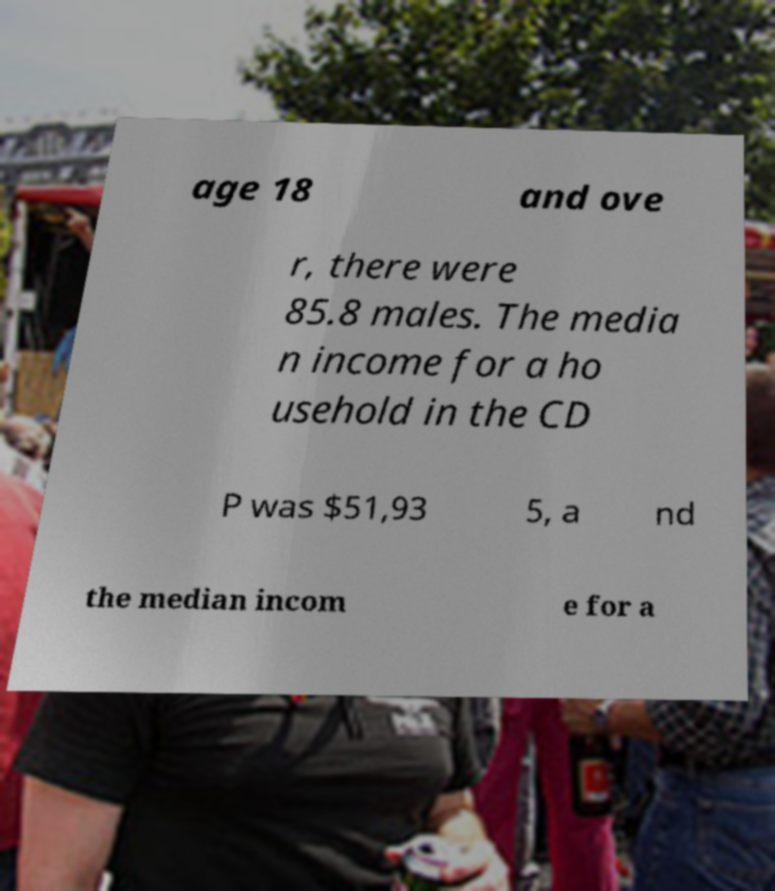There's text embedded in this image that I need extracted. Can you transcribe it verbatim? age 18 and ove r, there were 85.8 males. The media n income for a ho usehold in the CD P was $51,93 5, a nd the median incom e for a 